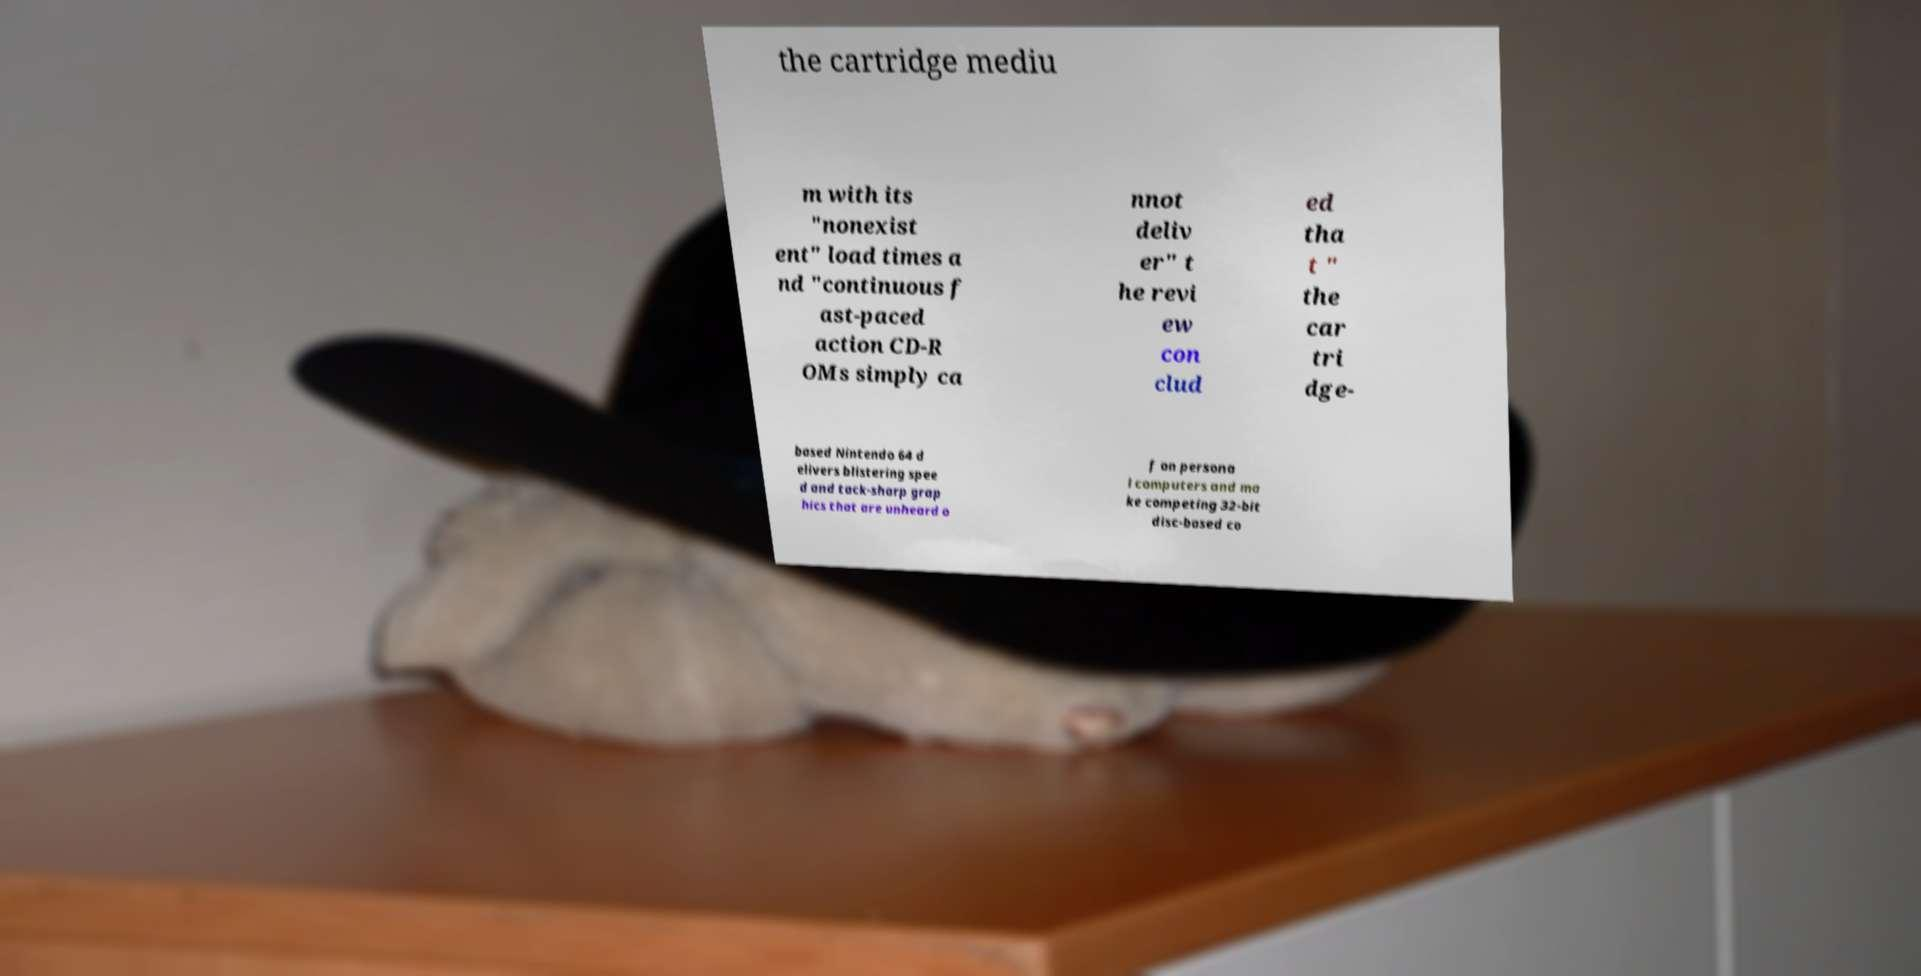Please identify and transcribe the text found in this image. the cartridge mediu m with its "nonexist ent" load times a nd "continuous f ast-paced action CD-R OMs simply ca nnot deliv er" t he revi ew con clud ed tha t " the car tri dge- based Nintendo 64 d elivers blistering spee d and tack-sharp grap hics that are unheard o f on persona l computers and ma ke competing 32-bit disc-based co 